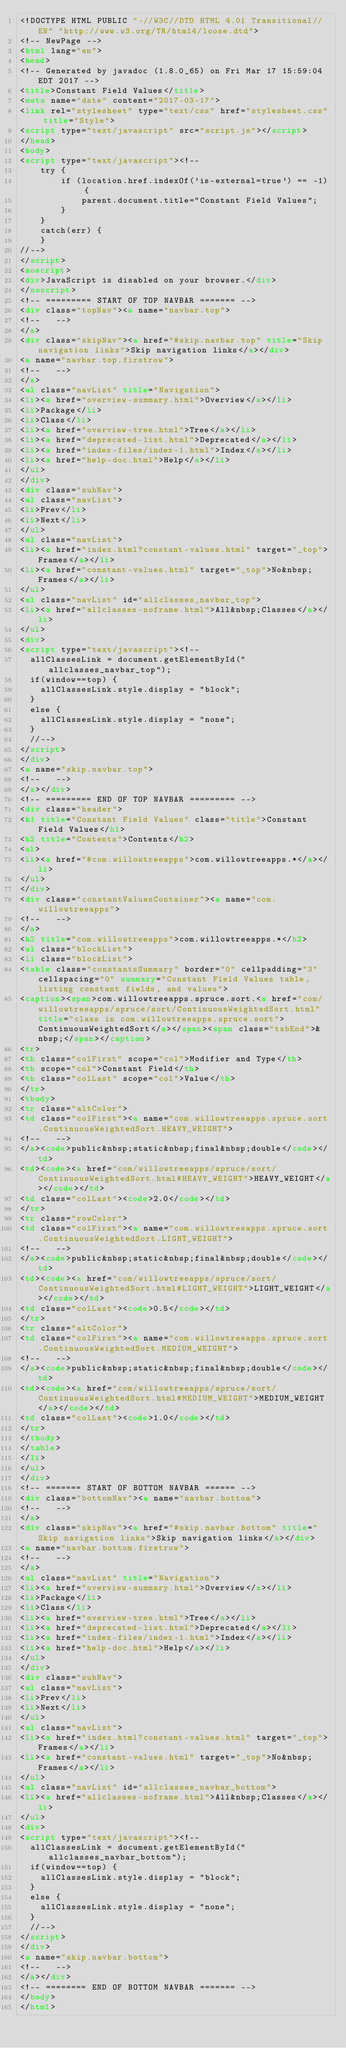Convert code to text. <code><loc_0><loc_0><loc_500><loc_500><_HTML_><!DOCTYPE HTML PUBLIC "-//W3C//DTD HTML 4.01 Transitional//EN" "http://www.w3.org/TR/html4/loose.dtd">
<!-- NewPage -->
<html lang="en">
<head>
<!-- Generated by javadoc (1.8.0_65) on Fri Mar 17 15:59:04 EDT 2017 -->
<title>Constant Field Values</title>
<meta name="date" content="2017-03-17">
<link rel="stylesheet" type="text/css" href="stylesheet.css" title="Style">
<script type="text/javascript" src="script.js"></script>
</head>
<body>
<script type="text/javascript"><!--
    try {
        if (location.href.indexOf('is-external=true') == -1) {
            parent.document.title="Constant Field Values";
        }
    }
    catch(err) {
    }
//-->
</script>
<noscript>
<div>JavaScript is disabled on your browser.</div>
</noscript>
<!-- ========= START OF TOP NAVBAR ======= -->
<div class="topNav"><a name="navbar.top">
<!--   -->
</a>
<div class="skipNav"><a href="#skip.navbar.top" title="Skip navigation links">Skip navigation links</a></div>
<a name="navbar.top.firstrow">
<!--   -->
</a>
<ul class="navList" title="Navigation">
<li><a href="overview-summary.html">Overview</a></li>
<li>Package</li>
<li>Class</li>
<li><a href="overview-tree.html">Tree</a></li>
<li><a href="deprecated-list.html">Deprecated</a></li>
<li><a href="index-files/index-1.html">Index</a></li>
<li><a href="help-doc.html">Help</a></li>
</ul>
</div>
<div class="subNav">
<ul class="navList">
<li>Prev</li>
<li>Next</li>
</ul>
<ul class="navList">
<li><a href="index.html?constant-values.html" target="_top">Frames</a></li>
<li><a href="constant-values.html" target="_top">No&nbsp;Frames</a></li>
</ul>
<ul class="navList" id="allclasses_navbar_top">
<li><a href="allclasses-noframe.html">All&nbsp;Classes</a></li>
</ul>
<div>
<script type="text/javascript"><!--
  allClassesLink = document.getElementById("allclasses_navbar_top");
  if(window==top) {
    allClassesLink.style.display = "block";
  }
  else {
    allClassesLink.style.display = "none";
  }
  //-->
</script>
</div>
<a name="skip.navbar.top">
<!--   -->
</a></div>
<!-- ========= END OF TOP NAVBAR ========= -->
<div class="header">
<h1 title="Constant Field Values" class="title">Constant Field Values</h1>
<h2 title="Contents">Contents</h2>
<ul>
<li><a href="#com.willowtreeapps">com.willowtreeapps.*</a></li>
</ul>
</div>
<div class="constantValuesContainer"><a name="com.willowtreeapps">
<!--   -->
</a>
<h2 title="com.willowtreeapps">com.willowtreeapps.*</h2>
<ul class="blockList">
<li class="blockList">
<table class="constantsSummary" border="0" cellpadding="3" cellspacing="0" summary="Constant Field Values table, listing constant fields, and values">
<caption><span>com.willowtreeapps.spruce.sort.<a href="com/willowtreeapps/spruce/sort/ContinuousWeightedSort.html" title="class in com.willowtreeapps.spruce.sort">ContinuousWeightedSort</a></span><span class="tabEnd">&nbsp;</span></caption>
<tr>
<th class="colFirst" scope="col">Modifier and Type</th>
<th scope="col">Constant Field</th>
<th class="colLast" scope="col">Value</th>
</tr>
<tbody>
<tr class="altColor">
<td class="colFirst"><a name="com.willowtreeapps.spruce.sort.ContinuousWeightedSort.HEAVY_WEIGHT">
<!--   -->
</a><code>public&nbsp;static&nbsp;final&nbsp;double</code></td>
<td><code><a href="com/willowtreeapps/spruce/sort/ContinuousWeightedSort.html#HEAVY_WEIGHT">HEAVY_WEIGHT</a></code></td>
<td class="colLast"><code>2.0</code></td>
</tr>
<tr class="rowColor">
<td class="colFirst"><a name="com.willowtreeapps.spruce.sort.ContinuousWeightedSort.LIGHT_WEIGHT">
<!--   -->
</a><code>public&nbsp;static&nbsp;final&nbsp;double</code></td>
<td><code><a href="com/willowtreeapps/spruce/sort/ContinuousWeightedSort.html#LIGHT_WEIGHT">LIGHT_WEIGHT</a></code></td>
<td class="colLast"><code>0.5</code></td>
</tr>
<tr class="altColor">
<td class="colFirst"><a name="com.willowtreeapps.spruce.sort.ContinuousWeightedSort.MEDIUM_WEIGHT">
<!--   -->
</a><code>public&nbsp;static&nbsp;final&nbsp;double</code></td>
<td><code><a href="com/willowtreeapps/spruce/sort/ContinuousWeightedSort.html#MEDIUM_WEIGHT">MEDIUM_WEIGHT</a></code></td>
<td class="colLast"><code>1.0</code></td>
</tr>
</tbody>
</table>
</li>
</ul>
</div>
<!-- ======= START OF BOTTOM NAVBAR ====== -->
<div class="bottomNav"><a name="navbar.bottom">
<!--   -->
</a>
<div class="skipNav"><a href="#skip.navbar.bottom" title="Skip navigation links">Skip navigation links</a></div>
<a name="navbar.bottom.firstrow">
<!--   -->
</a>
<ul class="navList" title="Navigation">
<li><a href="overview-summary.html">Overview</a></li>
<li>Package</li>
<li>Class</li>
<li><a href="overview-tree.html">Tree</a></li>
<li><a href="deprecated-list.html">Deprecated</a></li>
<li><a href="index-files/index-1.html">Index</a></li>
<li><a href="help-doc.html">Help</a></li>
</ul>
</div>
<div class="subNav">
<ul class="navList">
<li>Prev</li>
<li>Next</li>
</ul>
<ul class="navList">
<li><a href="index.html?constant-values.html" target="_top">Frames</a></li>
<li><a href="constant-values.html" target="_top">No&nbsp;Frames</a></li>
</ul>
<ul class="navList" id="allclasses_navbar_bottom">
<li><a href="allclasses-noframe.html">All&nbsp;Classes</a></li>
</ul>
<div>
<script type="text/javascript"><!--
  allClassesLink = document.getElementById("allclasses_navbar_bottom");
  if(window==top) {
    allClassesLink.style.display = "block";
  }
  else {
    allClassesLink.style.display = "none";
  }
  //-->
</script>
</div>
<a name="skip.navbar.bottom">
<!--   -->
</a></div>
<!-- ======== END OF BOTTOM NAVBAR ======= -->
</body>
</html>
</code> 